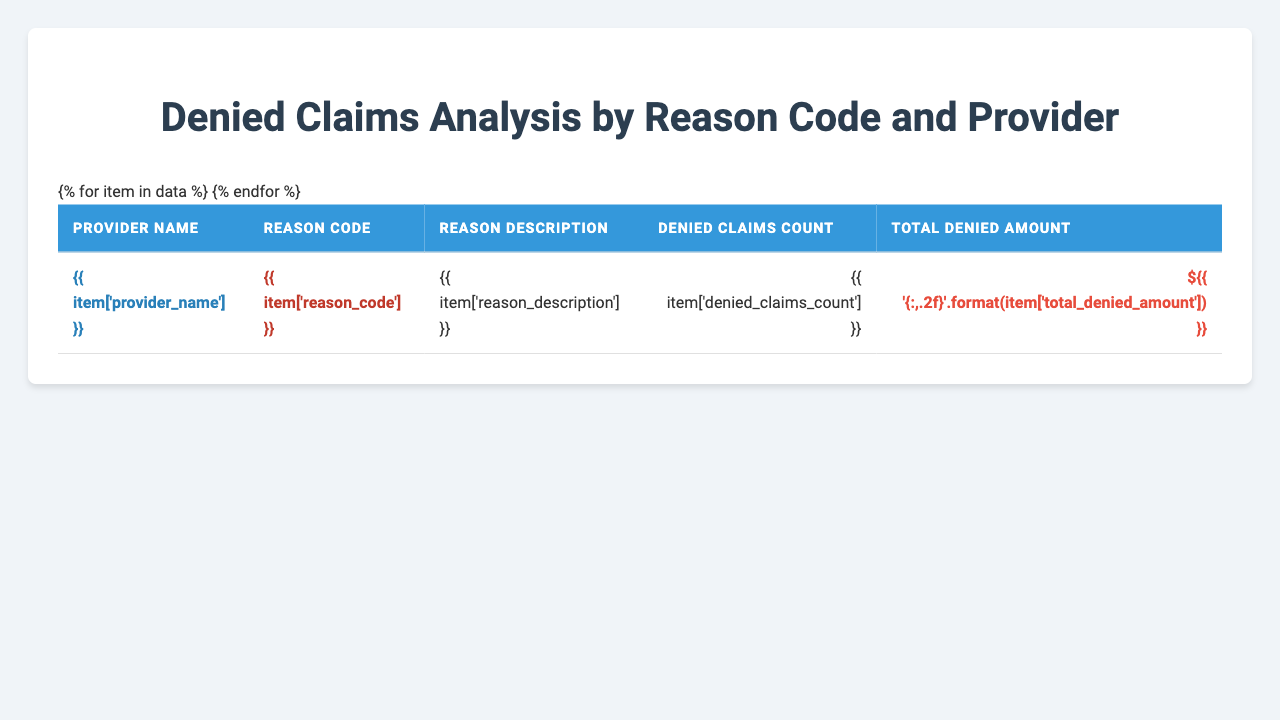What is the reason code with the highest number of denied claims at Mercy Hospital? Mercy Hospital has two reason codes listed: CO-16 with 127 denied claims and CO-97 with 84 denied claims. The highest number is CO-16, which has 127 denied claims.
Answer: CO-16 How many total denied claims does St. Luke's Medical Center have? St. Luke's Medical Center has two reason codes: CO-18 with 95 denied claims and CO-50 with 62 denied claims. Adding these together: 95 + 62 = 157.
Answer: 157 What is the total denied amount for claims denied for non-covered services at Mayo Clinic? At Mayo Clinic, the reason code CO-96 for non-covered charge(s) has 108 denied claims with a total denied amount of $52,364.70. Therefore, the total is $52,364.70.
Answer: $52,364.70 Which provider had the least total denied amount? The providers listed are Mercy Hospital, St. Luke's Medical Center, Cedars-Sinai Medical Center, Mayo Clinic, and Cleveland Clinic. Upon checking the total denied amounts: Mercy has $58,432.75, St. Luke's has $70,220.10, Cedars-Sinai has $60,411.15, Mayo has $88,877.10, and Cleveland has $47,588.10. The least total denied amount is for Cleveland Clinic at $47,588.10.
Answer: Cleveland Clinic Is there a claim denied for a duplicate service at Mercy Hospital? Mercy Hospital has reason codes CO-16 and CO-97. There is no mention of a duplicate claim/service (which would fall under CO-18). Therefore, there is no duplicate service claim denied at Mercy Hospital.
Answer: No What is the combined total denied amount for all claims denied at Cedars-Sinai Medical Center? Cedars-Sinai Medical Center has reason code CO-22 with a denied amount of $35,621.90 and CO-204 with $24,789.25. Adding them yields: $35,621.90 + $24,789.25 = $60,411.15.
Answer: $60,411.15 Which reason code caused the highest total denied amount overall, and what is that amount? Analyzing the total denied amounts for all reason codes listed, CO-96 at Mayo Clinic has the highest amount of $52,364.70. The next highest is CO-16 at Mercy Hospital with $58,432.75. The highest total denied amount is thus for CO-16, which stands at $58,432.75.
Answer: $58,432.75 How many denied claims are there in total among all listed providers? To find the total denied claims, we sum all the denied claims counts listed: 127 (Mercy) + 84 (Mercy) + 95 (St. Luke's) + 62 (St. Luke's) + 73 (Cedars-Sinai) + 51 (Cedars-Sinai) + 108 (Mayo) + 69 (Mayo) + 56 (Cleveland) + 42 (Cleveland) =  794.
Answer: 794 Has any provider faced denied claims due to a service deemed not medically necessary? The data shows that Cedars-Sinai Medical Center has reason code CO-50 stating it was not deemed a medical necessity by the payer. Therefore, yes, this provider has faced denied claims for this reason.
Answer: Yes 